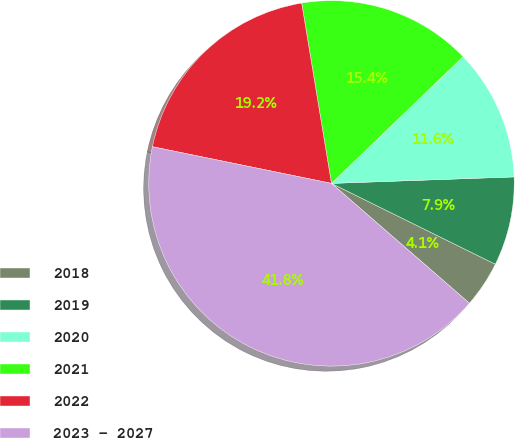<chart> <loc_0><loc_0><loc_500><loc_500><pie_chart><fcel>2018<fcel>2019<fcel>2020<fcel>2021<fcel>2022<fcel>2023 - 2027<nl><fcel>4.09%<fcel>7.86%<fcel>11.63%<fcel>15.41%<fcel>19.18%<fcel>41.83%<nl></chart> 